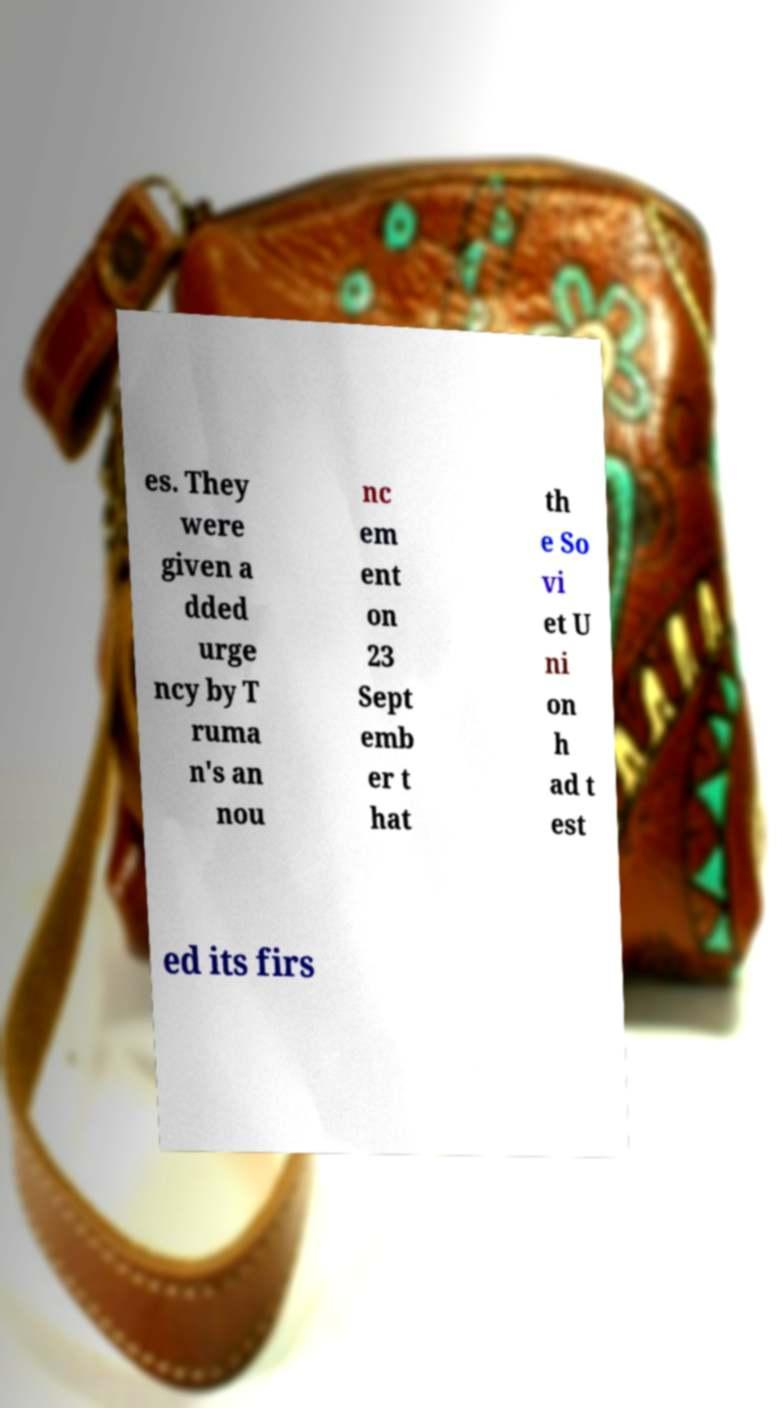Can you accurately transcribe the text from the provided image for me? es. They were given a dded urge ncy by T ruma n's an nou nc em ent on 23 Sept emb er t hat th e So vi et U ni on h ad t est ed its firs 